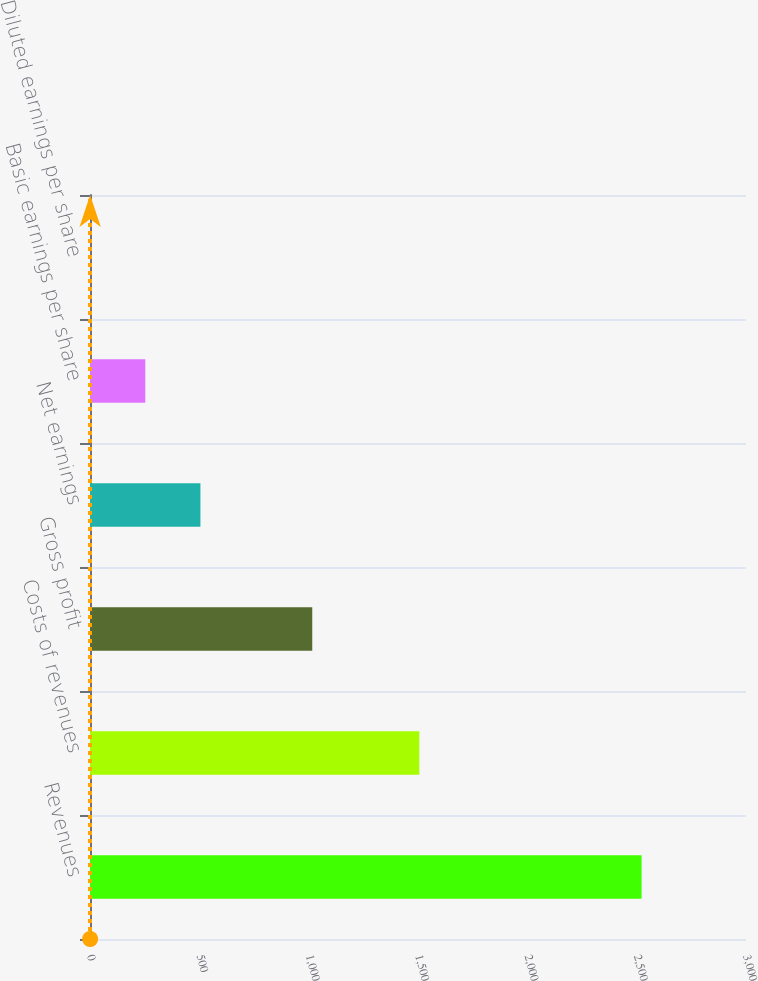<chart> <loc_0><loc_0><loc_500><loc_500><bar_chart><fcel>Revenues<fcel>Costs of revenues<fcel>Gross profit<fcel>Net earnings<fcel>Basic earnings per share<fcel>Diluted earnings per share<nl><fcel>2522.5<fcel>1506.1<fcel>1016.4<fcel>504.99<fcel>252.8<fcel>0.61<nl></chart> 